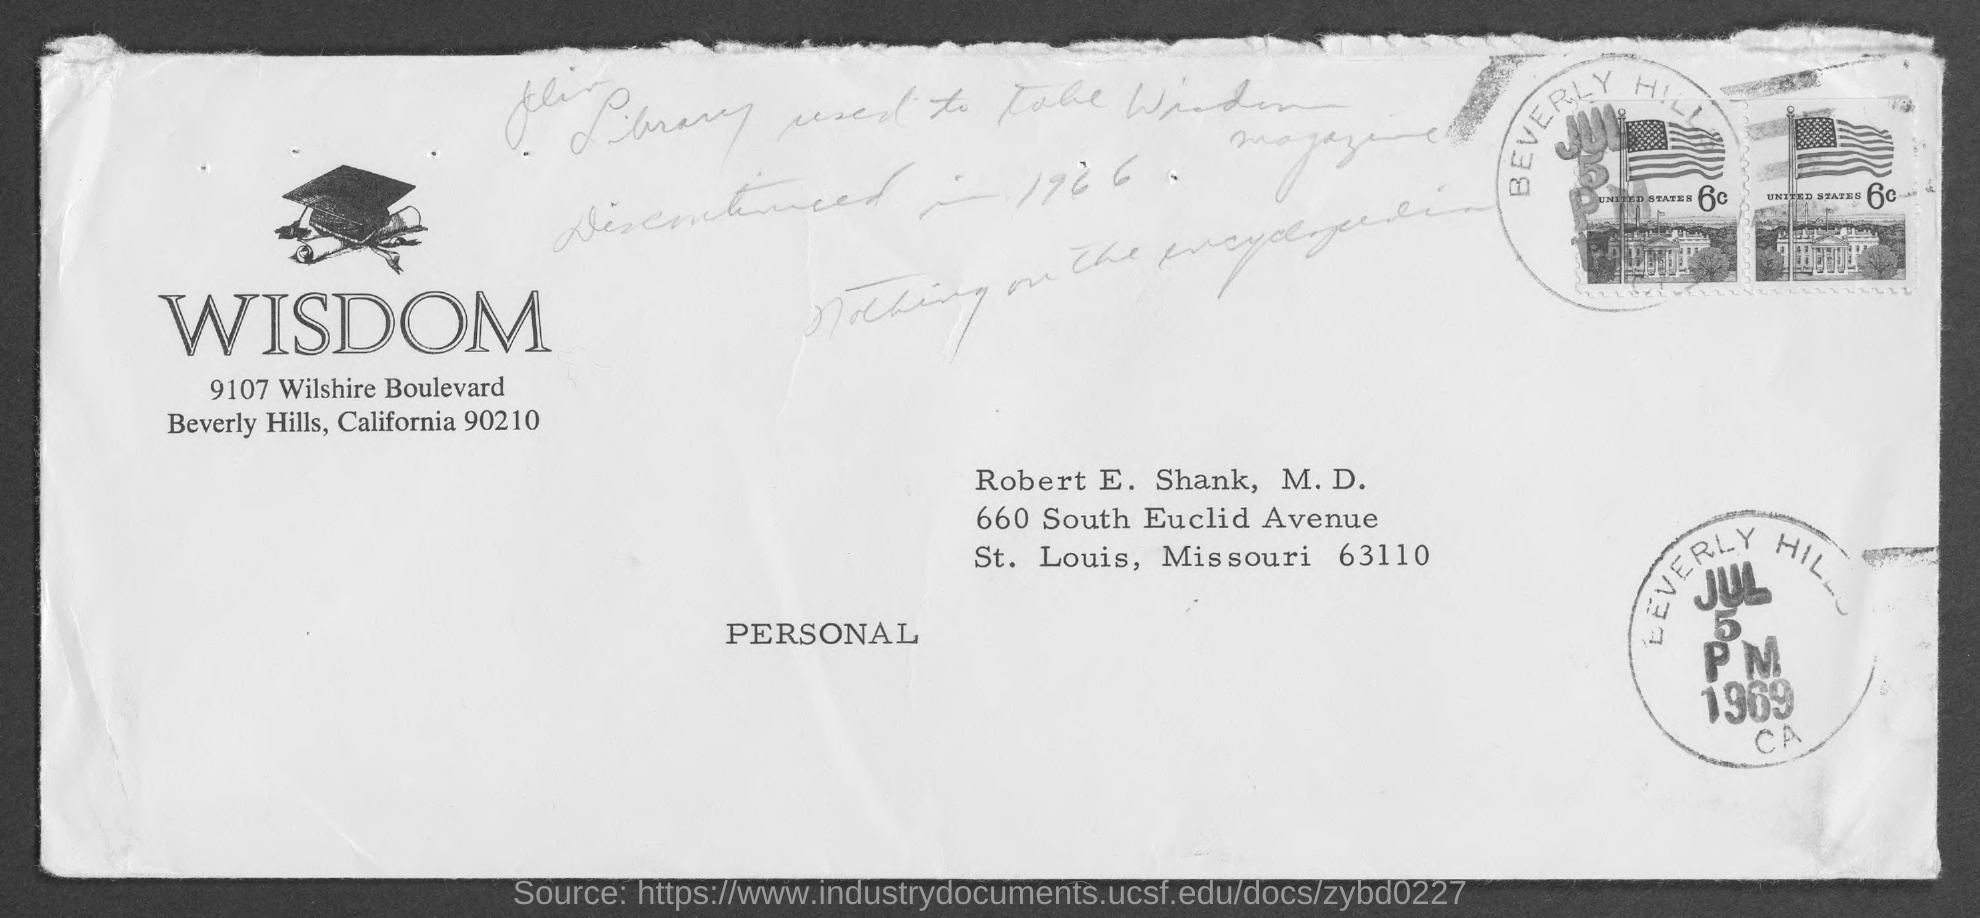Point out several critical features in this image. The letter is addressed to Robert E. Shank. 